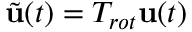Convert formula to latex. <formula><loc_0><loc_0><loc_500><loc_500>\tilde { u } ( t ) = T _ { r o t } u ( t )</formula> 